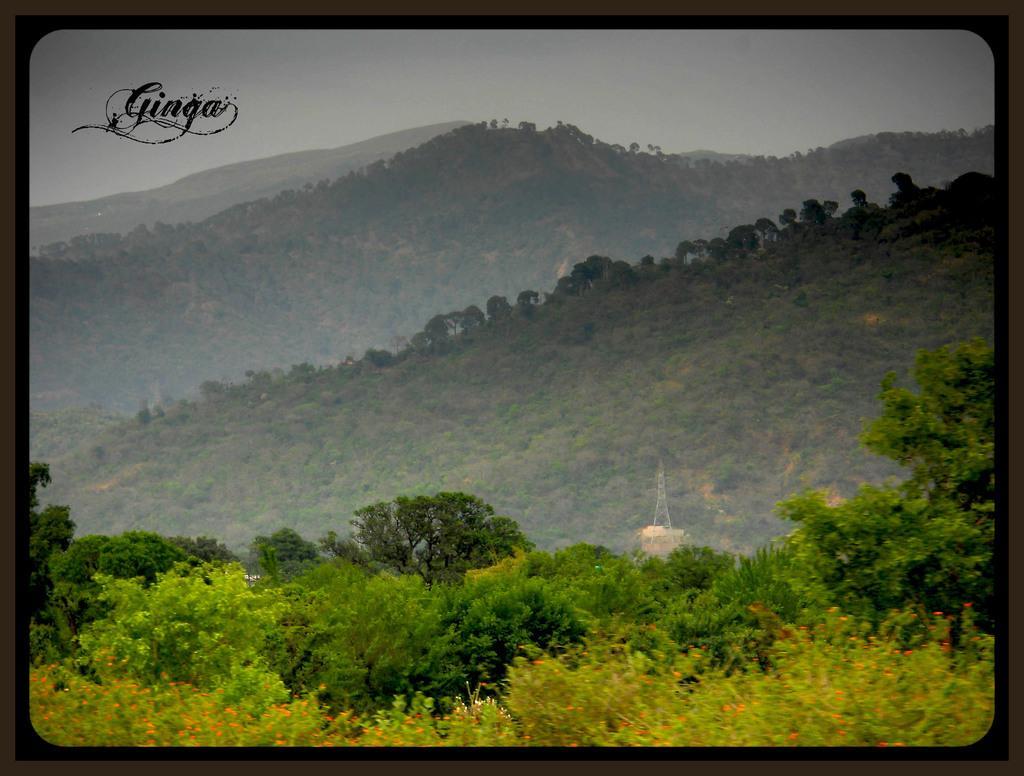Could you give a brief overview of what you see in this image? In this image, we can see so many trees, mountains, plants, flowers, transmission tower. Top of the image, there is a sky. On the left side, we can see a watermark in the image. The borders of the image, we can see a black color. 